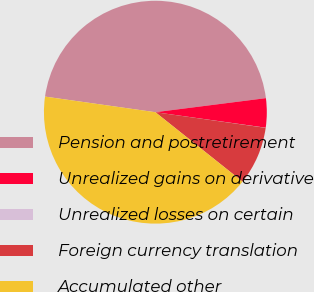<chart> <loc_0><loc_0><loc_500><loc_500><pie_chart><fcel>Pension and postretirement<fcel>Unrealized gains on derivative<fcel>Unrealized losses on certain<fcel>Foreign currency translation<fcel>Accumulated other<nl><fcel>45.75%<fcel>4.24%<fcel>0.02%<fcel>8.46%<fcel>41.53%<nl></chart> 